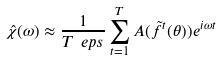Convert formula to latex. <formula><loc_0><loc_0><loc_500><loc_500>\hat { \chi } ( \omega ) \approx \frac { 1 } { T \ e p s } \sum _ { t = 1 } ^ { T } A ( \tilde { f } ^ { t } ( \theta ) ) e ^ { i \omega t }</formula> 